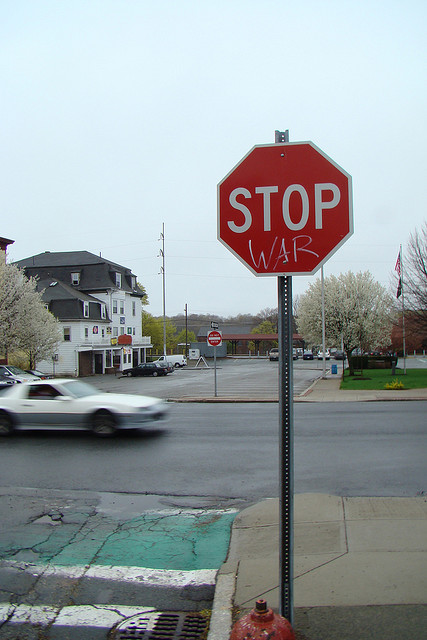What does the altered stop sign suggest about the community's stance on certain issues? The altered stop sign, showcasing the message 'STOP WAR,' speaks volumes about the community's stance on peace and its strong opposition to conflict. This form of street art serves not only as a plea for peace but also challenges passersby to reflect on the broader implications of war. Its placement in a prominent location suggests that this message is supported widely within the community, illustrating a collective desire for a more harmonious world. Such a public display of anti-war sentiment likely aims to provoke thought and discussion among residents and visitors, potentially stirring local engagement and activism. 